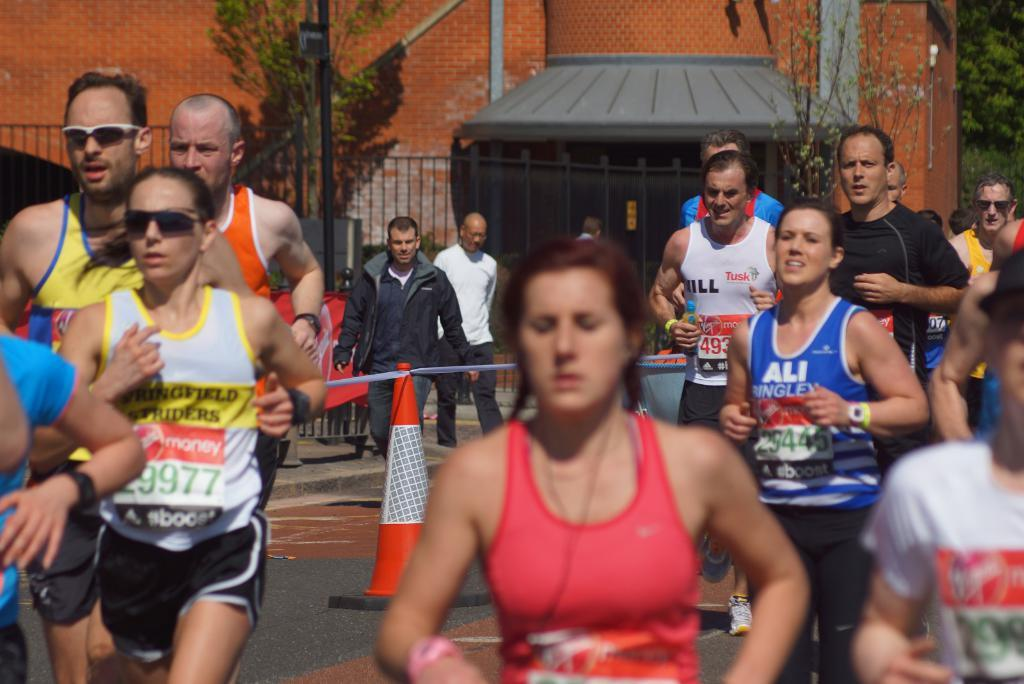<image>
Write a terse but informative summary of the picture. people in a running race wearing bibs from BOOST 